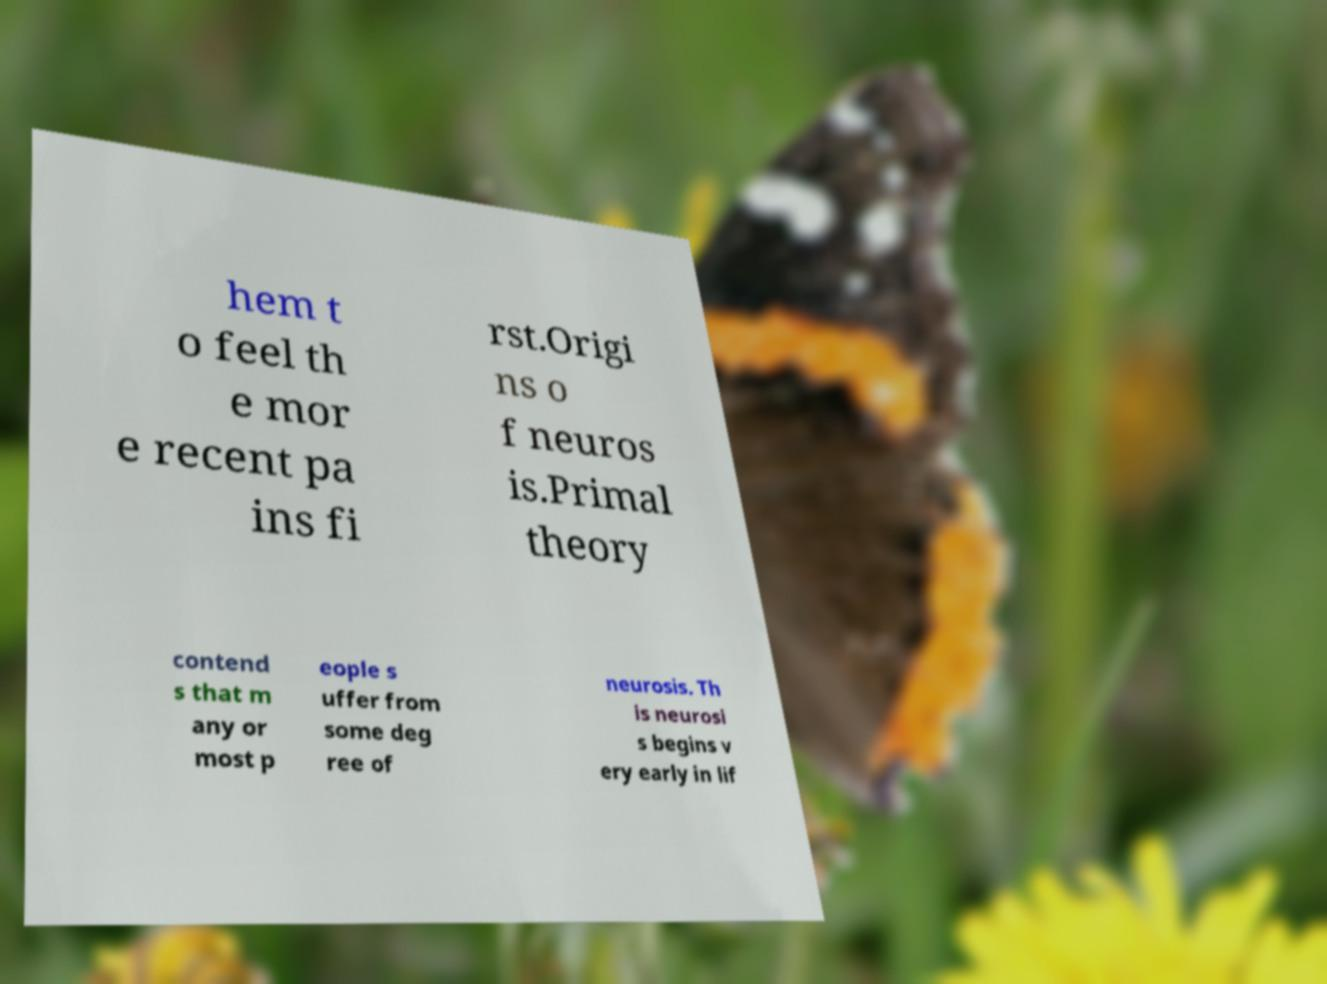For documentation purposes, I need the text within this image transcribed. Could you provide that? hem t o feel th e mor e recent pa ins fi rst.Origi ns o f neuros is.Primal theory contend s that m any or most p eople s uffer from some deg ree of neurosis. Th is neurosi s begins v ery early in lif 